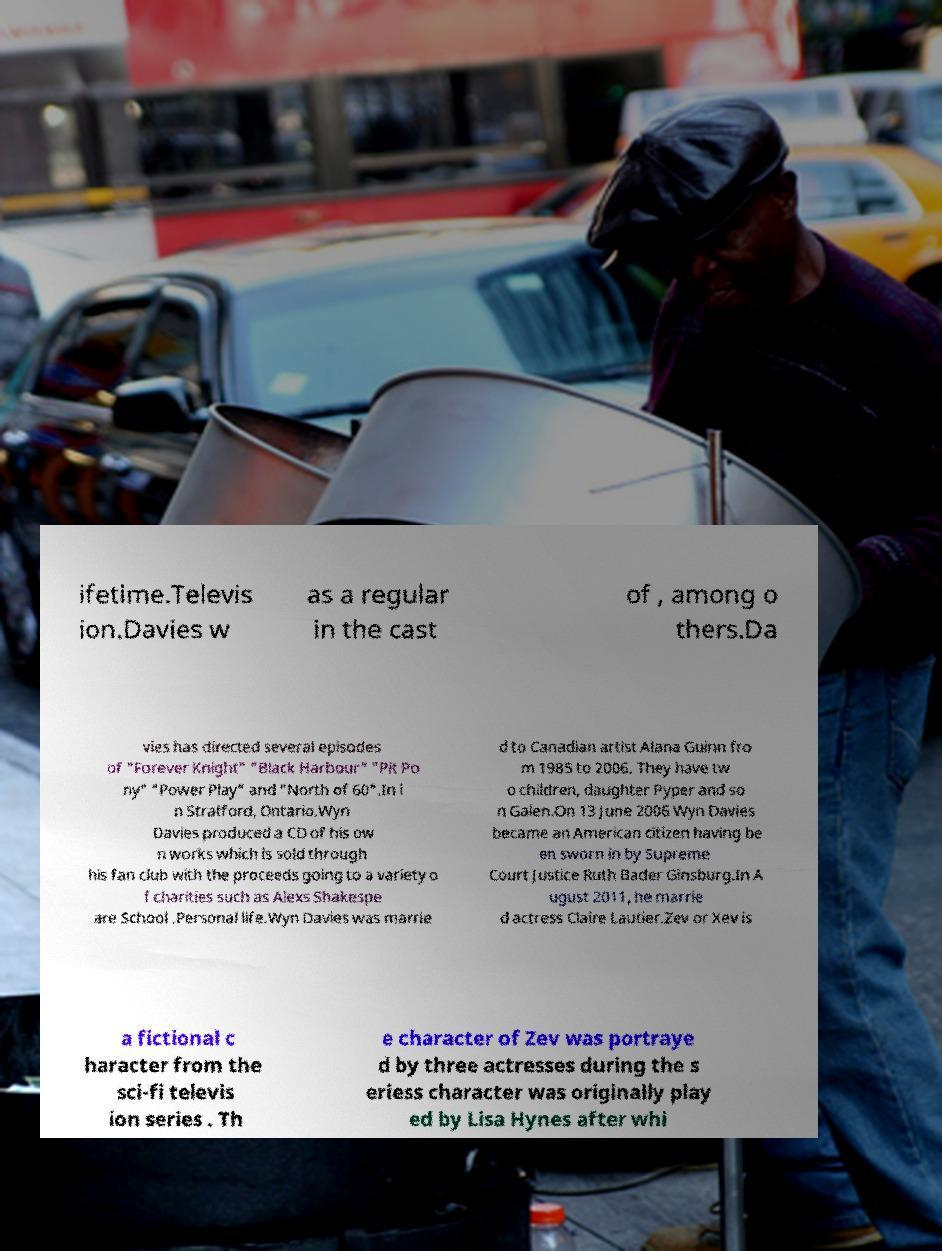I need the written content from this picture converted into text. Can you do that? ifetime.Televis ion.Davies w as a regular in the cast of , among o thers.Da vies has directed several episodes of "Forever Knight" "Black Harbour" "Pit Po ny" "Power Play" and "North of 60".In i n Stratford, Ontario.Wyn Davies produced a CD of his ow n works which is sold through his fan club with the proceeds going to a variety o f charities such as Alexs Shakespe are School .Personal life.Wyn Davies was marrie d to Canadian artist Alana Guinn fro m 1985 to 2006. They have tw o children, daughter Pyper and so n Galen.On 13 June 2006 Wyn Davies became an American citizen having be en sworn in by Supreme Court Justice Ruth Bader Ginsburg.In A ugust 2011, he marrie d actress Claire Lautier.Zev or Xev is a fictional c haracter from the sci-fi televis ion series . Th e character of Zev was portraye d by three actresses during the s eriess character was originally play ed by Lisa Hynes after whi 